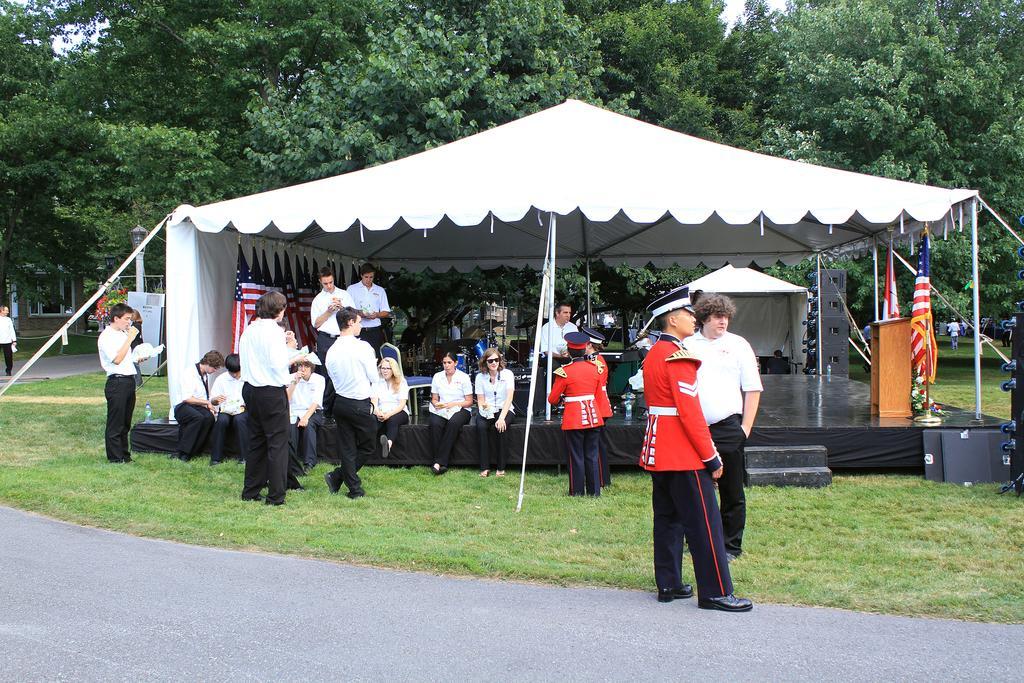Could you give a brief overview of what you see in this image? On the right side a man is standing, he wore a red color shirt, black color cap. On the left side there are few persons they wore white color shirts and black color trousers. This is the tenet, behind this there are green color trees. 